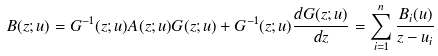<formula> <loc_0><loc_0><loc_500><loc_500>B ( z ; u ) = G ^ { - 1 } ( z ; u ) A ( z ; u ) G ( z ; u ) + G ^ { - 1 } ( z ; u ) \frac { d G ( z ; u ) } { d z } = \sum _ { i = 1 } ^ { n } \frac { B _ { i } ( u ) } { z - u _ { i } }</formula> 